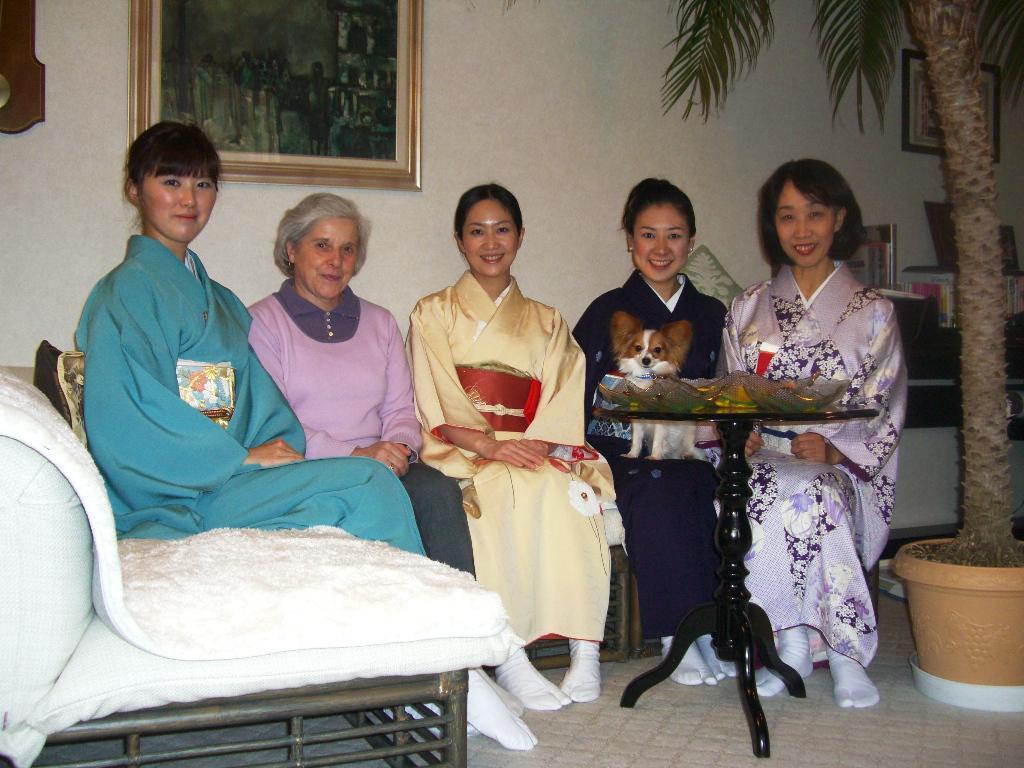Can you describe this image briefly? As we can see in the image there are few people sitting on sofa. There is a tree, pot, table, photo frame and a white color wall. 